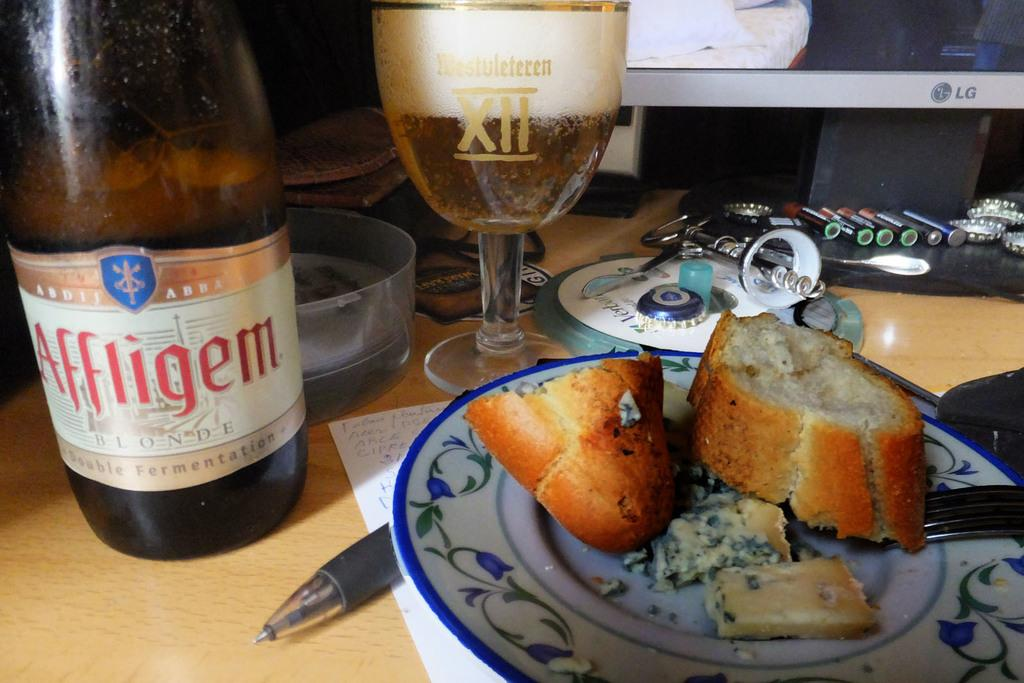<image>
Summarize the visual content of the image. Bread next to a large bottle of Affligem. 